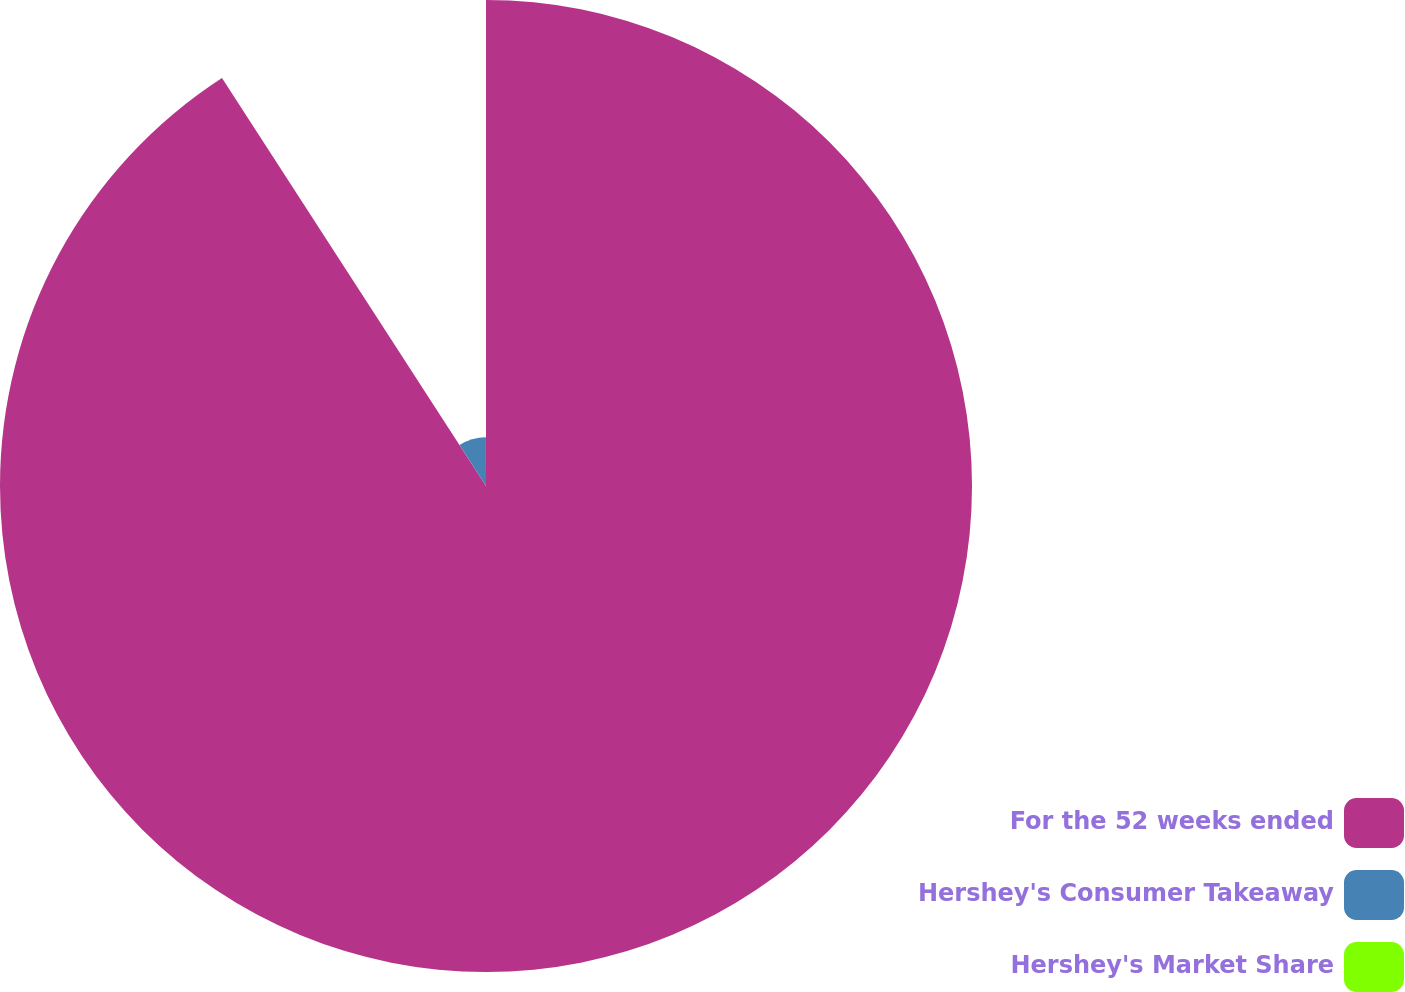Convert chart to OTSL. <chart><loc_0><loc_0><loc_500><loc_500><pie_chart><fcel>For the 52 weeks ended<fcel>Hershey's Consumer Takeaway<fcel>Hershey's Market Share<nl><fcel>90.86%<fcel>9.11%<fcel>0.03%<nl></chart> 